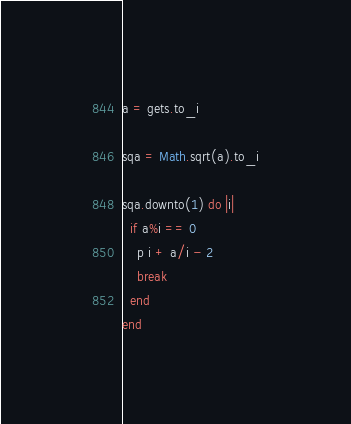<code> <loc_0><loc_0><loc_500><loc_500><_Ruby_>a = gets.to_i

sqa = Math.sqrt(a).to_i

sqa.downto(1) do |i|
  if a%i == 0
    p i + a/i - 2
    break
  end
end
</code> 